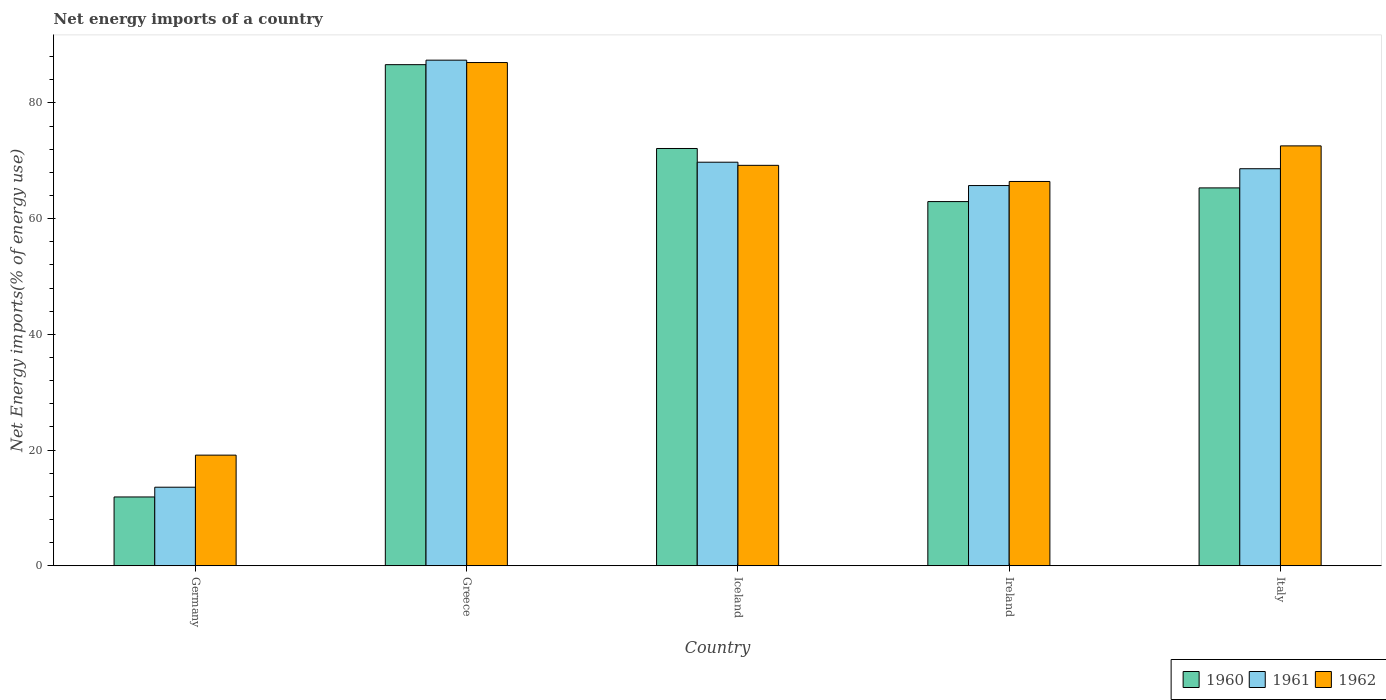Are the number of bars on each tick of the X-axis equal?
Provide a succinct answer. Yes. How many bars are there on the 2nd tick from the left?
Provide a succinct answer. 3. What is the net energy imports in 1960 in Ireland?
Provide a short and direct response. 62.95. Across all countries, what is the maximum net energy imports in 1960?
Ensure brevity in your answer.  86.62. Across all countries, what is the minimum net energy imports in 1960?
Ensure brevity in your answer.  11.9. In which country was the net energy imports in 1962 minimum?
Offer a very short reply. Germany. What is the total net energy imports in 1962 in the graph?
Offer a terse response. 314.33. What is the difference between the net energy imports in 1962 in Greece and that in Italy?
Keep it short and to the point. 14.4. What is the difference between the net energy imports in 1960 in Greece and the net energy imports in 1962 in Ireland?
Offer a terse response. 20.19. What is the average net energy imports in 1962 per country?
Offer a very short reply. 62.87. What is the difference between the net energy imports of/in 1962 and net energy imports of/in 1961 in Germany?
Ensure brevity in your answer.  5.54. What is the ratio of the net energy imports in 1962 in Germany to that in Ireland?
Your response must be concise. 0.29. Is the difference between the net energy imports in 1962 in Iceland and Ireland greater than the difference between the net energy imports in 1961 in Iceland and Ireland?
Offer a terse response. No. What is the difference between the highest and the second highest net energy imports in 1961?
Make the answer very short. -1.13. What is the difference between the highest and the lowest net energy imports in 1960?
Provide a short and direct response. 74.72. Is the sum of the net energy imports in 1961 in Germany and Greece greater than the maximum net energy imports in 1960 across all countries?
Offer a very short reply. Yes. What does the 3rd bar from the left in Italy represents?
Your answer should be compact. 1962. What does the 3rd bar from the right in Italy represents?
Make the answer very short. 1960. Is it the case that in every country, the sum of the net energy imports in 1960 and net energy imports in 1961 is greater than the net energy imports in 1962?
Your response must be concise. Yes. How many bars are there?
Offer a very short reply. 15. How many countries are there in the graph?
Your answer should be compact. 5. What is the difference between two consecutive major ticks on the Y-axis?
Keep it short and to the point. 20. Are the values on the major ticks of Y-axis written in scientific E-notation?
Offer a very short reply. No. Does the graph contain grids?
Provide a short and direct response. No. Where does the legend appear in the graph?
Keep it short and to the point. Bottom right. How many legend labels are there?
Make the answer very short. 3. What is the title of the graph?
Provide a short and direct response. Net energy imports of a country. What is the label or title of the X-axis?
Provide a succinct answer. Country. What is the label or title of the Y-axis?
Make the answer very short. Net Energy imports(% of energy use). What is the Net Energy imports(% of energy use) in 1960 in Germany?
Give a very brief answer. 11.9. What is the Net Energy imports(% of energy use) of 1961 in Germany?
Give a very brief answer. 13.58. What is the Net Energy imports(% of energy use) in 1962 in Germany?
Provide a short and direct response. 19.13. What is the Net Energy imports(% of energy use) of 1960 in Greece?
Provide a short and direct response. 86.62. What is the Net Energy imports(% of energy use) in 1961 in Greece?
Your answer should be very brief. 87.4. What is the Net Energy imports(% of energy use) in 1962 in Greece?
Provide a short and direct response. 86.98. What is the Net Energy imports(% of energy use) of 1960 in Iceland?
Give a very brief answer. 72.13. What is the Net Energy imports(% of energy use) in 1961 in Iceland?
Ensure brevity in your answer.  69.76. What is the Net Energy imports(% of energy use) in 1962 in Iceland?
Give a very brief answer. 69.22. What is the Net Energy imports(% of energy use) in 1960 in Ireland?
Your answer should be compact. 62.95. What is the Net Energy imports(% of energy use) in 1961 in Ireland?
Provide a short and direct response. 65.72. What is the Net Energy imports(% of energy use) of 1962 in Ireland?
Offer a terse response. 66.43. What is the Net Energy imports(% of energy use) in 1960 in Italy?
Your answer should be very brief. 65.32. What is the Net Energy imports(% of energy use) of 1961 in Italy?
Provide a succinct answer. 68.63. What is the Net Energy imports(% of energy use) of 1962 in Italy?
Provide a short and direct response. 72.58. Across all countries, what is the maximum Net Energy imports(% of energy use) in 1960?
Provide a succinct answer. 86.62. Across all countries, what is the maximum Net Energy imports(% of energy use) of 1961?
Make the answer very short. 87.4. Across all countries, what is the maximum Net Energy imports(% of energy use) of 1962?
Your answer should be compact. 86.98. Across all countries, what is the minimum Net Energy imports(% of energy use) of 1960?
Your answer should be very brief. 11.9. Across all countries, what is the minimum Net Energy imports(% of energy use) in 1961?
Give a very brief answer. 13.58. Across all countries, what is the minimum Net Energy imports(% of energy use) of 1962?
Give a very brief answer. 19.13. What is the total Net Energy imports(% of energy use) of 1960 in the graph?
Provide a succinct answer. 298.91. What is the total Net Energy imports(% of energy use) of 1961 in the graph?
Give a very brief answer. 305.09. What is the total Net Energy imports(% of energy use) in 1962 in the graph?
Make the answer very short. 314.33. What is the difference between the Net Energy imports(% of energy use) of 1960 in Germany and that in Greece?
Give a very brief answer. -74.72. What is the difference between the Net Energy imports(% of energy use) of 1961 in Germany and that in Greece?
Ensure brevity in your answer.  -73.81. What is the difference between the Net Energy imports(% of energy use) in 1962 in Germany and that in Greece?
Your answer should be very brief. -67.86. What is the difference between the Net Energy imports(% of energy use) in 1960 in Germany and that in Iceland?
Provide a succinct answer. -60.23. What is the difference between the Net Energy imports(% of energy use) in 1961 in Germany and that in Iceland?
Your answer should be very brief. -56.17. What is the difference between the Net Energy imports(% of energy use) in 1962 in Germany and that in Iceland?
Keep it short and to the point. -50.09. What is the difference between the Net Energy imports(% of energy use) of 1960 in Germany and that in Ireland?
Your response must be concise. -51.05. What is the difference between the Net Energy imports(% of energy use) in 1961 in Germany and that in Ireland?
Keep it short and to the point. -52.14. What is the difference between the Net Energy imports(% of energy use) in 1962 in Germany and that in Ireland?
Provide a succinct answer. -47.3. What is the difference between the Net Energy imports(% of energy use) of 1960 in Germany and that in Italy?
Keep it short and to the point. -53.42. What is the difference between the Net Energy imports(% of energy use) in 1961 in Germany and that in Italy?
Make the answer very short. -55.05. What is the difference between the Net Energy imports(% of energy use) in 1962 in Germany and that in Italy?
Give a very brief answer. -53.45. What is the difference between the Net Energy imports(% of energy use) in 1960 in Greece and that in Iceland?
Offer a terse response. 14.49. What is the difference between the Net Energy imports(% of energy use) of 1961 in Greece and that in Iceland?
Provide a succinct answer. 17.64. What is the difference between the Net Energy imports(% of energy use) in 1962 in Greece and that in Iceland?
Your response must be concise. 17.77. What is the difference between the Net Energy imports(% of energy use) in 1960 in Greece and that in Ireland?
Offer a terse response. 23.66. What is the difference between the Net Energy imports(% of energy use) of 1961 in Greece and that in Ireland?
Your response must be concise. 21.67. What is the difference between the Net Energy imports(% of energy use) in 1962 in Greece and that in Ireland?
Provide a succinct answer. 20.56. What is the difference between the Net Energy imports(% of energy use) of 1960 in Greece and that in Italy?
Provide a short and direct response. 21.3. What is the difference between the Net Energy imports(% of energy use) in 1961 in Greece and that in Italy?
Give a very brief answer. 18.77. What is the difference between the Net Energy imports(% of energy use) of 1962 in Greece and that in Italy?
Your answer should be very brief. 14.4. What is the difference between the Net Energy imports(% of energy use) of 1960 in Iceland and that in Ireland?
Your answer should be compact. 9.18. What is the difference between the Net Energy imports(% of energy use) in 1961 in Iceland and that in Ireland?
Make the answer very short. 4.03. What is the difference between the Net Energy imports(% of energy use) of 1962 in Iceland and that in Ireland?
Offer a terse response. 2.79. What is the difference between the Net Energy imports(% of energy use) of 1960 in Iceland and that in Italy?
Keep it short and to the point. 6.81. What is the difference between the Net Energy imports(% of energy use) of 1961 in Iceland and that in Italy?
Offer a very short reply. 1.13. What is the difference between the Net Energy imports(% of energy use) in 1962 in Iceland and that in Italy?
Offer a very short reply. -3.36. What is the difference between the Net Energy imports(% of energy use) of 1960 in Ireland and that in Italy?
Provide a succinct answer. -2.36. What is the difference between the Net Energy imports(% of energy use) in 1961 in Ireland and that in Italy?
Offer a terse response. -2.91. What is the difference between the Net Energy imports(% of energy use) of 1962 in Ireland and that in Italy?
Your answer should be very brief. -6.15. What is the difference between the Net Energy imports(% of energy use) in 1960 in Germany and the Net Energy imports(% of energy use) in 1961 in Greece?
Give a very brief answer. -75.5. What is the difference between the Net Energy imports(% of energy use) in 1960 in Germany and the Net Energy imports(% of energy use) in 1962 in Greece?
Provide a short and direct response. -75.08. What is the difference between the Net Energy imports(% of energy use) in 1961 in Germany and the Net Energy imports(% of energy use) in 1962 in Greece?
Your answer should be very brief. -73.4. What is the difference between the Net Energy imports(% of energy use) of 1960 in Germany and the Net Energy imports(% of energy use) of 1961 in Iceland?
Ensure brevity in your answer.  -57.86. What is the difference between the Net Energy imports(% of energy use) of 1960 in Germany and the Net Energy imports(% of energy use) of 1962 in Iceland?
Offer a very short reply. -57.32. What is the difference between the Net Energy imports(% of energy use) of 1961 in Germany and the Net Energy imports(% of energy use) of 1962 in Iceland?
Keep it short and to the point. -55.63. What is the difference between the Net Energy imports(% of energy use) of 1960 in Germany and the Net Energy imports(% of energy use) of 1961 in Ireland?
Give a very brief answer. -53.82. What is the difference between the Net Energy imports(% of energy use) in 1960 in Germany and the Net Energy imports(% of energy use) in 1962 in Ireland?
Offer a very short reply. -54.53. What is the difference between the Net Energy imports(% of energy use) in 1961 in Germany and the Net Energy imports(% of energy use) in 1962 in Ireland?
Give a very brief answer. -52.84. What is the difference between the Net Energy imports(% of energy use) of 1960 in Germany and the Net Energy imports(% of energy use) of 1961 in Italy?
Your response must be concise. -56.73. What is the difference between the Net Energy imports(% of energy use) of 1960 in Germany and the Net Energy imports(% of energy use) of 1962 in Italy?
Keep it short and to the point. -60.68. What is the difference between the Net Energy imports(% of energy use) in 1961 in Germany and the Net Energy imports(% of energy use) in 1962 in Italy?
Your answer should be compact. -59. What is the difference between the Net Energy imports(% of energy use) in 1960 in Greece and the Net Energy imports(% of energy use) in 1961 in Iceland?
Provide a succinct answer. 16.86. What is the difference between the Net Energy imports(% of energy use) of 1960 in Greece and the Net Energy imports(% of energy use) of 1962 in Iceland?
Ensure brevity in your answer.  17.4. What is the difference between the Net Energy imports(% of energy use) of 1961 in Greece and the Net Energy imports(% of energy use) of 1962 in Iceland?
Provide a succinct answer. 18.18. What is the difference between the Net Energy imports(% of energy use) in 1960 in Greece and the Net Energy imports(% of energy use) in 1961 in Ireland?
Offer a terse response. 20.89. What is the difference between the Net Energy imports(% of energy use) in 1960 in Greece and the Net Energy imports(% of energy use) in 1962 in Ireland?
Provide a short and direct response. 20.19. What is the difference between the Net Energy imports(% of energy use) in 1961 in Greece and the Net Energy imports(% of energy use) in 1962 in Ireland?
Provide a short and direct response. 20.97. What is the difference between the Net Energy imports(% of energy use) in 1960 in Greece and the Net Energy imports(% of energy use) in 1961 in Italy?
Keep it short and to the point. 17.99. What is the difference between the Net Energy imports(% of energy use) of 1960 in Greece and the Net Energy imports(% of energy use) of 1962 in Italy?
Provide a succinct answer. 14.04. What is the difference between the Net Energy imports(% of energy use) of 1961 in Greece and the Net Energy imports(% of energy use) of 1962 in Italy?
Your answer should be very brief. 14.82. What is the difference between the Net Energy imports(% of energy use) in 1960 in Iceland and the Net Energy imports(% of energy use) in 1961 in Ireland?
Ensure brevity in your answer.  6.41. What is the difference between the Net Energy imports(% of energy use) in 1960 in Iceland and the Net Energy imports(% of energy use) in 1962 in Ireland?
Make the answer very short. 5.7. What is the difference between the Net Energy imports(% of energy use) in 1961 in Iceland and the Net Energy imports(% of energy use) in 1962 in Ireland?
Provide a succinct answer. 3.33. What is the difference between the Net Energy imports(% of energy use) in 1960 in Iceland and the Net Energy imports(% of energy use) in 1961 in Italy?
Ensure brevity in your answer.  3.5. What is the difference between the Net Energy imports(% of energy use) in 1960 in Iceland and the Net Energy imports(% of energy use) in 1962 in Italy?
Make the answer very short. -0.45. What is the difference between the Net Energy imports(% of energy use) in 1961 in Iceland and the Net Energy imports(% of energy use) in 1962 in Italy?
Give a very brief answer. -2.82. What is the difference between the Net Energy imports(% of energy use) in 1960 in Ireland and the Net Energy imports(% of energy use) in 1961 in Italy?
Ensure brevity in your answer.  -5.68. What is the difference between the Net Energy imports(% of energy use) of 1960 in Ireland and the Net Energy imports(% of energy use) of 1962 in Italy?
Your answer should be compact. -9.63. What is the difference between the Net Energy imports(% of energy use) of 1961 in Ireland and the Net Energy imports(% of energy use) of 1962 in Italy?
Give a very brief answer. -6.86. What is the average Net Energy imports(% of energy use) in 1960 per country?
Offer a very short reply. 59.78. What is the average Net Energy imports(% of energy use) of 1961 per country?
Offer a terse response. 61.02. What is the average Net Energy imports(% of energy use) in 1962 per country?
Your answer should be very brief. 62.87. What is the difference between the Net Energy imports(% of energy use) of 1960 and Net Energy imports(% of energy use) of 1961 in Germany?
Ensure brevity in your answer.  -1.68. What is the difference between the Net Energy imports(% of energy use) in 1960 and Net Energy imports(% of energy use) in 1962 in Germany?
Your answer should be very brief. -7.23. What is the difference between the Net Energy imports(% of energy use) of 1961 and Net Energy imports(% of energy use) of 1962 in Germany?
Offer a very short reply. -5.54. What is the difference between the Net Energy imports(% of energy use) of 1960 and Net Energy imports(% of energy use) of 1961 in Greece?
Offer a terse response. -0.78. What is the difference between the Net Energy imports(% of energy use) of 1960 and Net Energy imports(% of energy use) of 1962 in Greece?
Keep it short and to the point. -0.37. What is the difference between the Net Energy imports(% of energy use) in 1961 and Net Energy imports(% of energy use) in 1962 in Greece?
Provide a short and direct response. 0.41. What is the difference between the Net Energy imports(% of energy use) of 1960 and Net Energy imports(% of energy use) of 1961 in Iceland?
Your answer should be compact. 2.37. What is the difference between the Net Energy imports(% of energy use) of 1960 and Net Energy imports(% of energy use) of 1962 in Iceland?
Your answer should be compact. 2.91. What is the difference between the Net Energy imports(% of energy use) in 1961 and Net Energy imports(% of energy use) in 1962 in Iceland?
Give a very brief answer. 0.54. What is the difference between the Net Energy imports(% of energy use) of 1960 and Net Energy imports(% of energy use) of 1961 in Ireland?
Keep it short and to the point. -2.77. What is the difference between the Net Energy imports(% of energy use) of 1960 and Net Energy imports(% of energy use) of 1962 in Ireland?
Offer a very short reply. -3.47. What is the difference between the Net Energy imports(% of energy use) of 1961 and Net Energy imports(% of energy use) of 1962 in Ireland?
Your answer should be compact. -0.7. What is the difference between the Net Energy imports(% of energy use) in 1960 and Net Energy imports(% of energy use) in 1961 in Italy?
Give a very brief answer. -3.31. What is the difference between the Net Energy imports(% of energy use) in 1960 and Net Energy imports(% of energy use) in 1962 in Italy?
Make the answer very short. -7.26. What is the difference between the Net Energy imports(% of energy use) in 1961 and Net Energy imports(% of energy use) in 1962 in Italy?
Your answer should be compact. -3.95. What is the ratio of the Net Energy imports(% of energy use) of 1960 in Germany to that in Greece?
Offer a very short reply. 0.14. What is the ratio of the Net Energy imports(% of energy use) in 1961 in Germany to that in Greece?
Keep it short and to the point. 0.16. What is the ratio of the Net Energy imports(% of energy use) of 1962 in Germany to that in Greece?
Make the answer very short. 0.22. What is the ratio of the Net Energy imports(% of energy use) of 1960 in Germany to that in Iceland?
Make the answer very short. 0.17. What is the ratio of the Net Energy imports(% of energy use) in 1961 in Germany to that in Iceland?
Offer a terse response. 0.19. What is the ratio of the Net Energy imports(% of energy use) of 1962 in Germany to that in Iceland?
Your answer should be very brief. 0.28. What is the ratio of the Net Energy imports(% of energy use) of 1960 in Germany to that in Ireland?
Give a very brief answer. 0.19. What is the ratio of the Net Energy imports(% of energy use) in 1961 in Germany to that in Ireland?
Make the answer very short. 0.21. What is the ratio of the Net Energy imports(% of energy use) in 1962 in Germany to that in Ireland?
Make the answer very short. 0.29. What is the ratio of the Net Energy imports(% of energy use) of 1960 in Germany to that in Italy?
Ensure brevity in your answer.  0.18. What is the ratio of the Net Energy imports(% of energy use) of 1961 in Germany to that in Italy?
Provide a succinct answer. 0.2. What is the ratio of the Net Energy imports(% of energy use) of 1962 in Germany to that in Italy?
Offer a very short reply. 0.26. What is the ratio of the Net Energy imports(% of energy use) in 1960 in Greece to that in Iceland?
Provide a short and direct response. 1.2. What is the ratio of the Net Energy imports(% of energy use) in 1961 in Greece to that in Iceland?
Make the answer very short. 1.25. What is the ratio of the Net Energy imports(% of energy use) of 1962 in Greece to that in Iceland?
Provide a short and direct response. 1.26. What is the ratio of the Net Energy imports(% of energy use) in 1960 in Greece to that in Ireland?
Your answer should be compact. 1.38. What is the ratio of the Net Energy imports(% of energy use) of 1961 in Greece to that in Ireland?
Your answer should be compact. 1.33. What is the ratio of the Net Energy imports(% of energy use) in 1962 in Greece to that in Ireland?
Ensure brevity in your answer.  1.31. What is the ratio of the Net Energy imports(% of energy use) in 1960 in Greece to that in Italy?
Offer a terse response. 1.33. What is the ratio of the Net Energy imports(% of energy use) of 1961 in Greece to that in Italy?
Your answer should be compact. 1.27. What is the ratio of the Net Energy imports(% of energy use) of 1962 in Greece to that in Italy?
Make the answer very short. 1.2. What is the ratio of the Net Energy imports(% of energy use) of 1960 in Iceland to that in Ireland?
Provide a succinct answer. 1.15. What is the ratio of the Net Energy imports(% of energy use) of 1961 in Iceland to that in Ireland?
Provide a succinct answer. 1.06. What is the ratio of the Net Energy imports(% of energy use) in 1962 in Iceland to that in Ireland?
Make the answer very short. 1.04. What is the ratio of the Net Energy imports(% of energy use) in 1960 in Iceland to that in Italy?
Ensure brevity in your answer.  1.1. What is the ratio of the Net Energy imports(% of energy use) in 1961 in Iceland to that in Italy?
Keep it short and to the point. 1.02. What is the ratio of the Net Energy imports(% of energy use) in 1962 in Iceland to that in Italy?
Ensure brevity in your answer.  0.95. What is the ratio of the Net Energy imports(% of energy use) of 1960 in Ireland to that in Italy?
Offer a terse response. 0.96. What is the ratio of the Net Energy imports(% of energy use) of 1961 in Ireland to that in Italy?
Offer a very short reply. 0.96. What is the ratio of the Net Energy imports(% of energy use) of 1962 in Ireland to that in Italy?
Give a very brief answer. 0.92. What is the difference between the highest and the second highest Net Energy imports(% of energy use) in 1960?
Provide a succinct answer. 14.49. What is the difference between the highest and the second highest Net Energy imports(% of energy use) in 1961?
Your answer should be very brief. 17.64. What is the difference between the highest and the second highest Net Energy imports(% of energy use) in 1962?
Your answer should be very brief. 14.4. What is the difference between the highest and the lowest Net Energy imports(% of energy use) of 1960?
Your answer should be very brief. 74.72. What is the difference between the highest and the lowest Net Energy imports(% of energy use) of 1961?
Keep it short and to the point. 73.81. What is the difference between the highest and the lowest Net Energy imports(% of energy use) in 1962?
Keep it short and to the point. 67.86. 